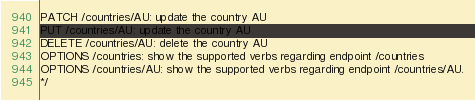<code> <loc_0><loc_0><loc_500><loc_500><_PHP_>PATCH /countries/AU: update the country AU
PUT /countries/AU: update the country AU
DELETE /countries/AU: delete the country AU
OPTIONS /countries: show the supported verbs regarding endpoint /countries
OPTIONS /countries/AU: show the supported verbs regarding endpoint /countries/AU.
*/</code> 